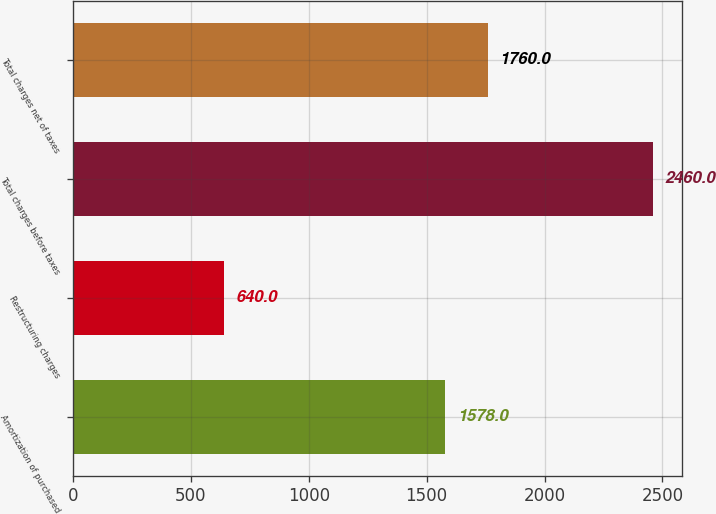Convert chart to OTSL. <chart><loc_0><loc_0><loc_500><loc_500><bar_chart><fcel>Amortization of purchased<fcel>Restructuring charges<fcel>Total charges before taxes<fcel>Total charges net of taxes<nl><fcel>1578<fcel>640<fcel>2460<fcel>1760<nl></chart> 